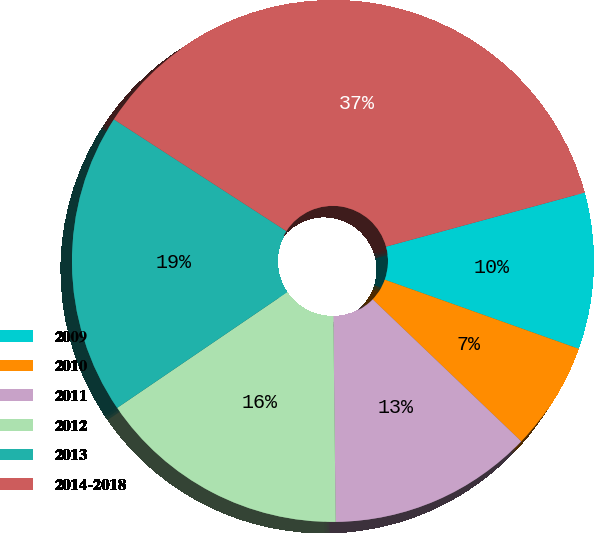Convert chart. <chart><loc_0><loc_0><loc_500><loc_500><pie_chart><fcel>2009<fcel>2010<fcel>2011<fcel>2012<fcel>2013<fcel>2014-2018<nl><fcel>9.68%<fcel>6.69%<fcel>12.68%<fcel>15.67%<fcel>18.66%<fcel>36.62%<nl></chart> 